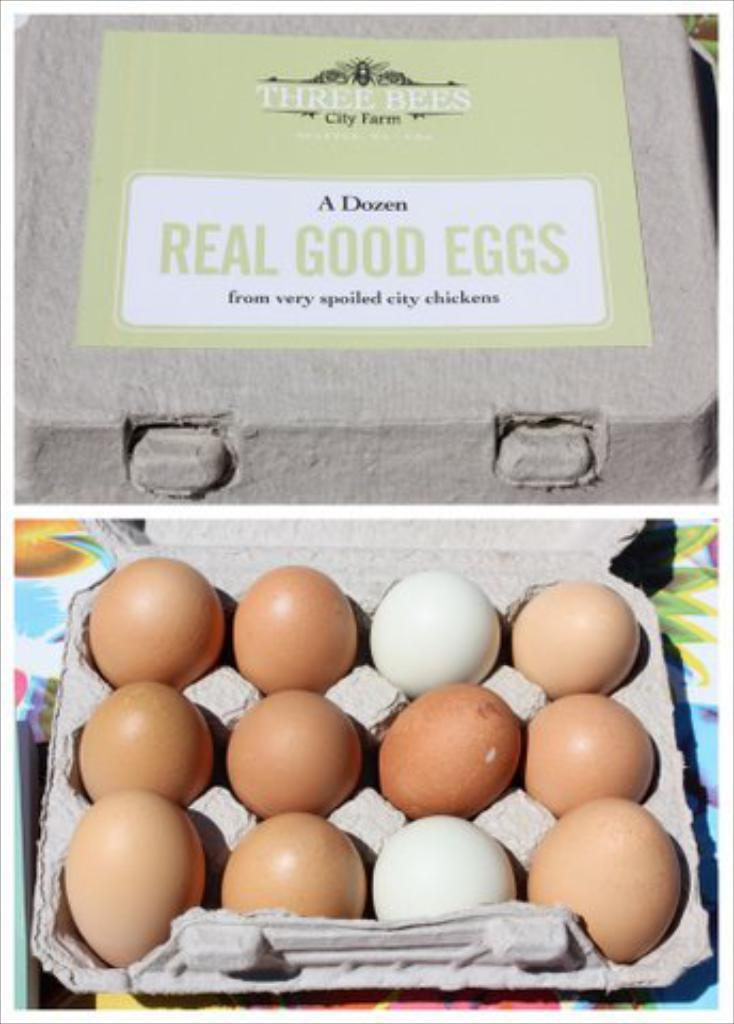What type of food item is present in the image? There are eggs in the image. How are the eggs arranged in the image? The eggs are kept in an egg tray. What can be seen behind the egg tray in the image? There is an object behind the egg tray. Can you describe any additional details in the image? There is a sticker with names in the image. What type of ball can be seen rolling off the edge in the image? There is no ball present in the image, nor is there any indication of an edge. 